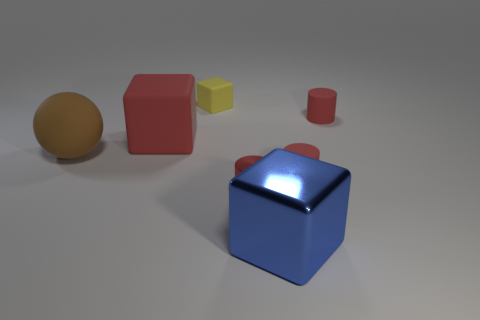Do the large blue metallic object and the large brown rubber object in front of the large red rubber block have the same shape?
Provide a short and direct response. No. How big is the thing that is both behind the large matte block and on the right side of the tiny shiny thing?
Your answer should be very brief. Small. The matte thing that is both on the right side of the big red thing and to the left of the metal block is what color?
Your response must be concise. Yellow. Is there anything else that is the same material as the yellow block?
Keep it short and to the point. Yes. Are there fewer brown rubber spheres that are right of the large blue object than tiny yellow rubber blocks that are in front of the small yellow block?
Your answer should be compact. No. Is there any other thing that is the same color as the rubber ball?
Your answer should be compact. No. What is the shape of the large shiny object?
Make the answer very short. Cube. What color is the other big object that is made of the same material as the big brown object?
Your answer should be very brief. Red. Is the number of brown objects greater than the number of cyan balls?
Provide a short and direct response. Yes. Is there a big brown matte thing?
Your answer should be very brief. Yes. 